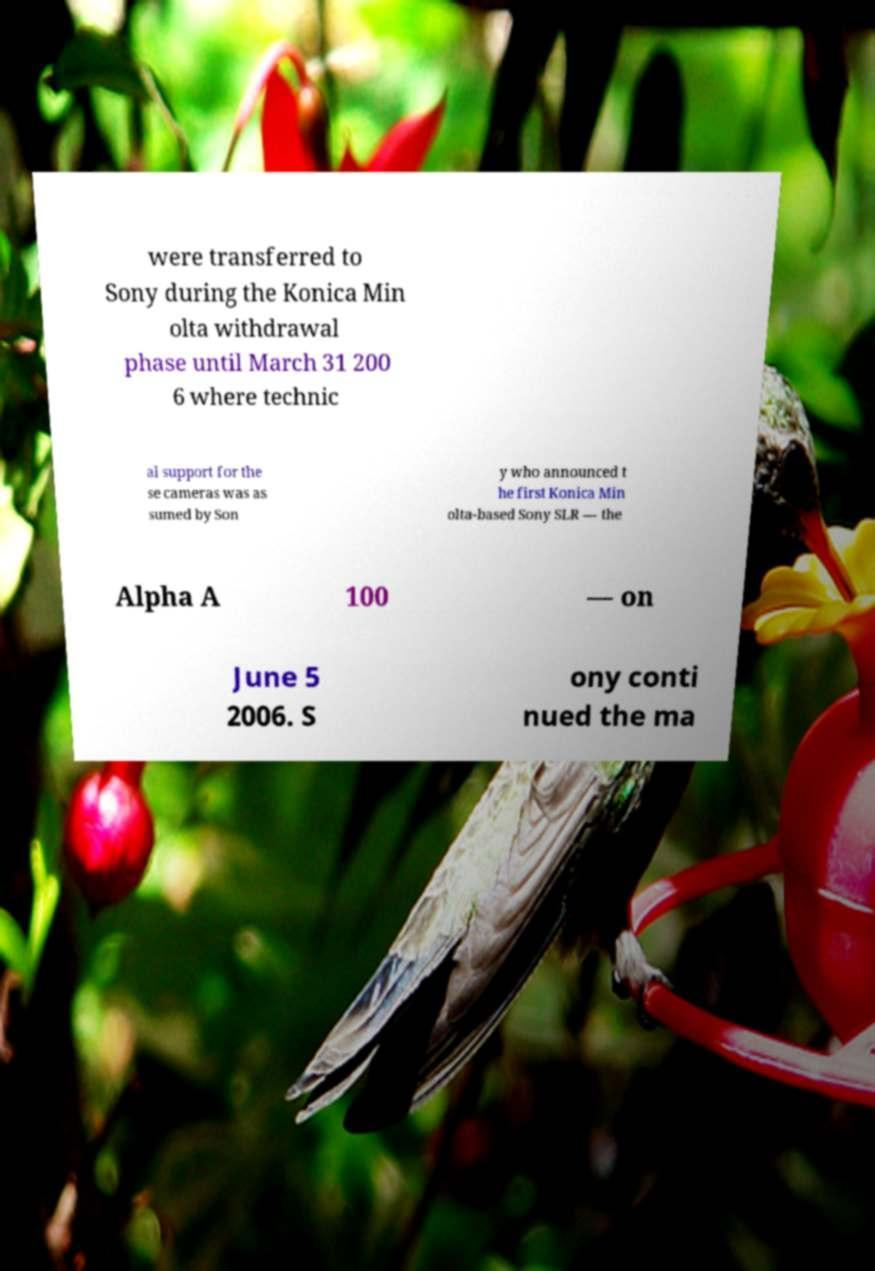Can you accurately transcribe the text from the provided image for me? were transferred to Sony during the Konica Min olta withdrawal phase until March 31 200 6 where technic al support for the se cameras was as sumed by Son y who announced t he first Konica Min olta-based Sony SLR — the Alpha A 100 — on June 5 2006. S ony conti nued the ma 